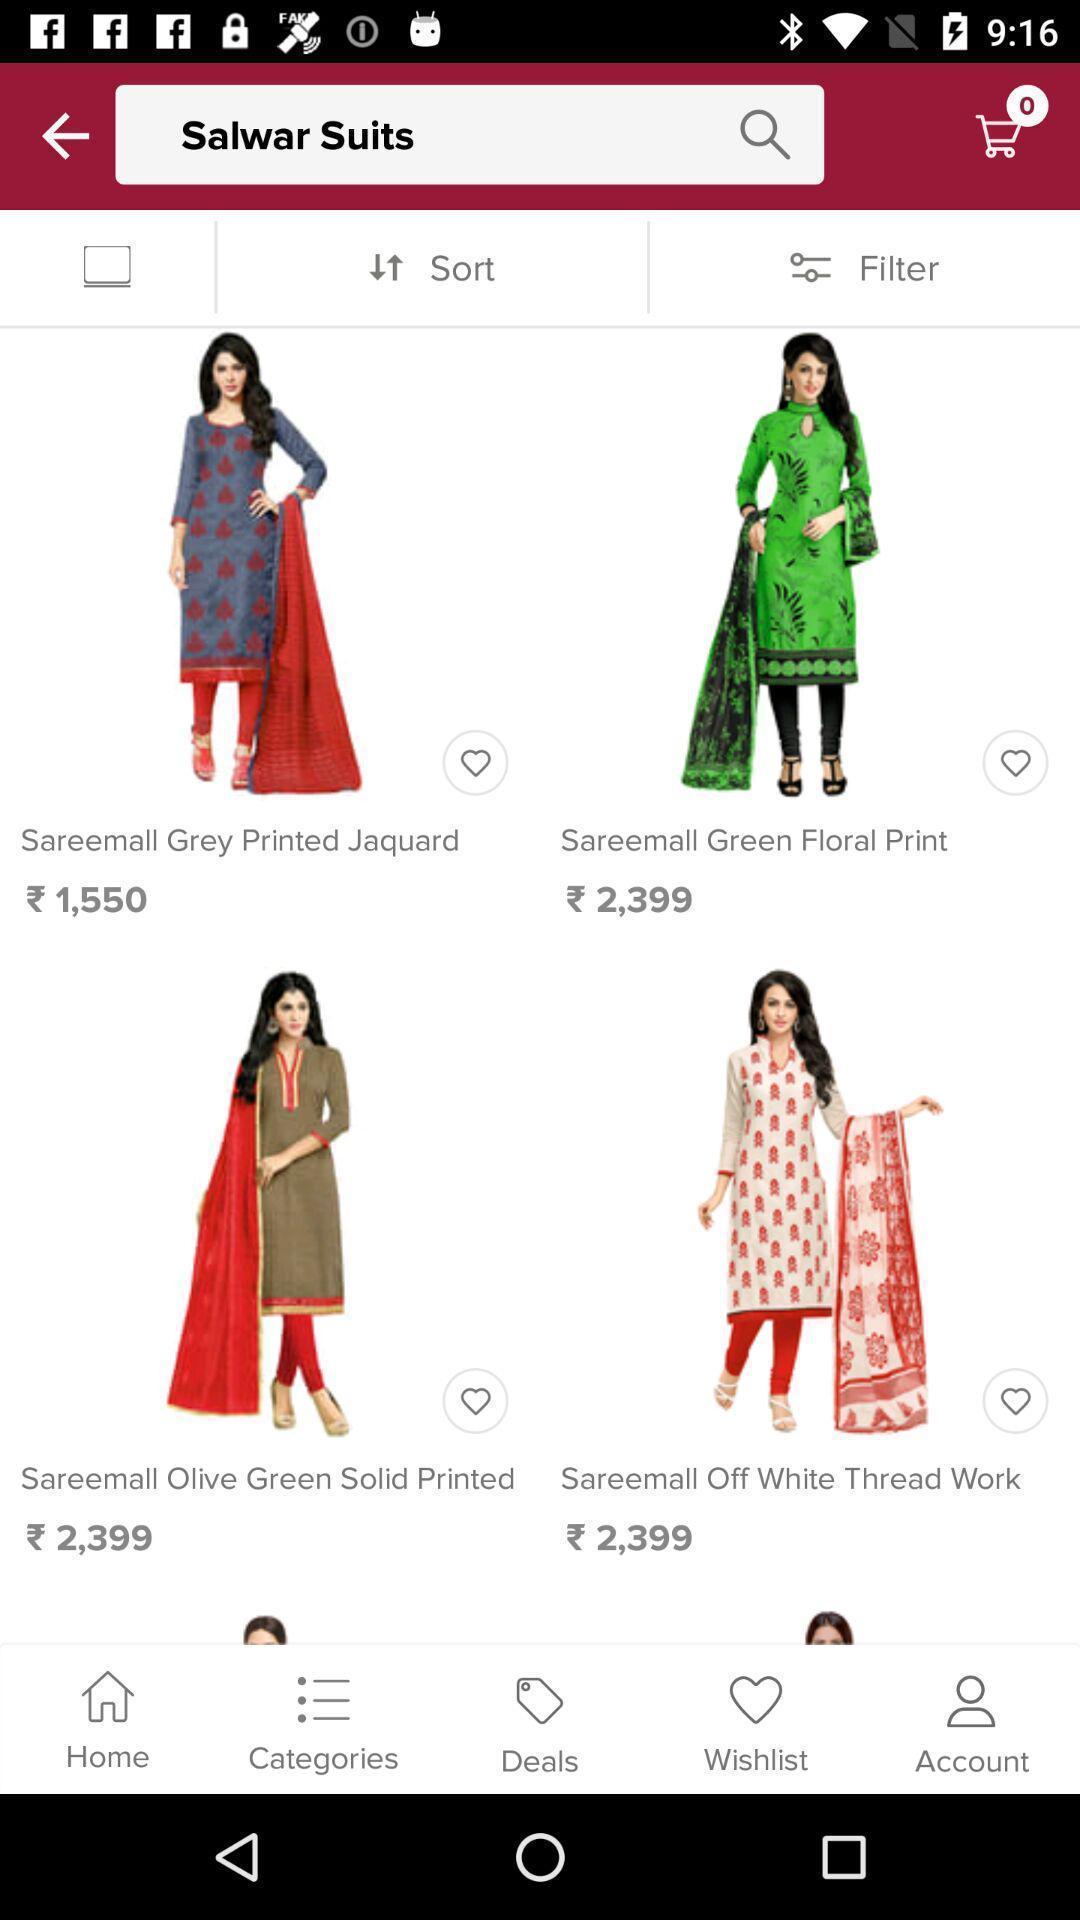Summarize the main components in this picture. Screen page of shopping app. 